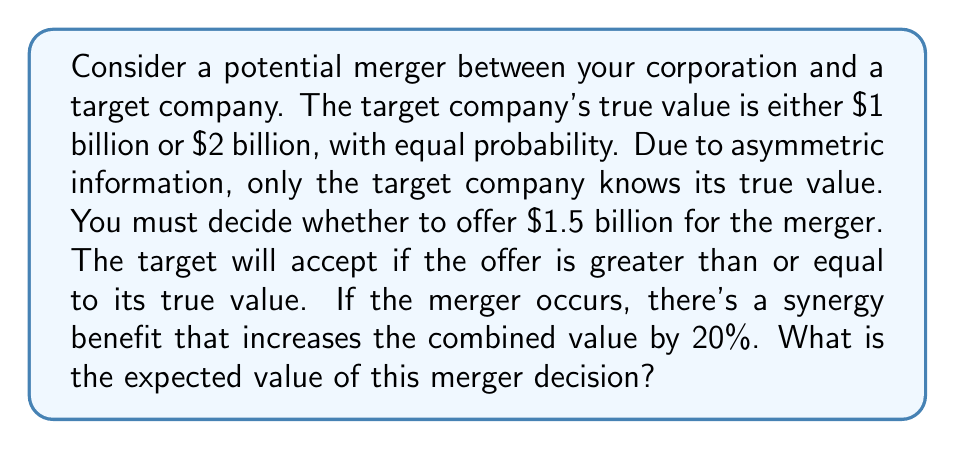Give your solution to this math problem. Let's approach this step-by-step:

1) First, let's define our variables:
   $V_L = 1$ billion (low value)
   $V_H = 2$ billion (high value)
   $O = 1.5$ billion (offer)
   $S = 20\%$ (synergy benefit)

2) The target will accept the offer if its true value is less than or equal to the offer. This means it will accept when its value is $V_L$, but reject when its value is $V_H$.

3) If the merger occurs (when target value is $V_L$):
   - Cost to acquirer: $O = 1.5$ billion
   - Value acquired: $V_L = 1$ billion
   - Synergy benefit: $S \times V_L = 0.2 \times 1 = 0.2$ billion
   - Net value: $V_L + (S \times V_L) - O = 1 + 0.2 - 1.5 = -0.3$ billion

4) If the merger doesn't occur (when target value is $V_H$):
   - Net value: $0$ (no gain, no loss)

5) The probability of each scenario is 0.5 (equal probability of $V_L$ and $V_H$)

6) Expected value calculation:
   $$E = 0.5 \times (-0.3) + 0.5 \times 0 = -0.15$$ billion

Therefore, the expected value of this merger decision is -$0.15 billion or -$150 million.
Answer: The expected value of the merger decision is -$150 million. 